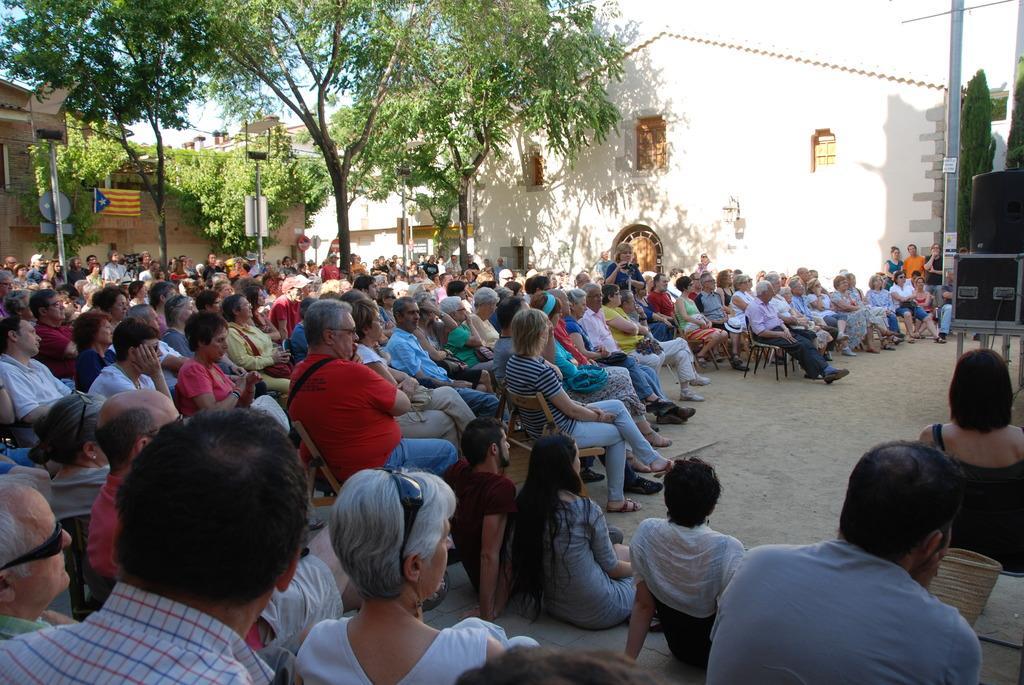Please provide a concise description of this image. In this image I can see number of persons are sitting on chairs and few persons are sitting on the ground. In the background I can see few trees, a flag, few poles, few buildings and the sky. 